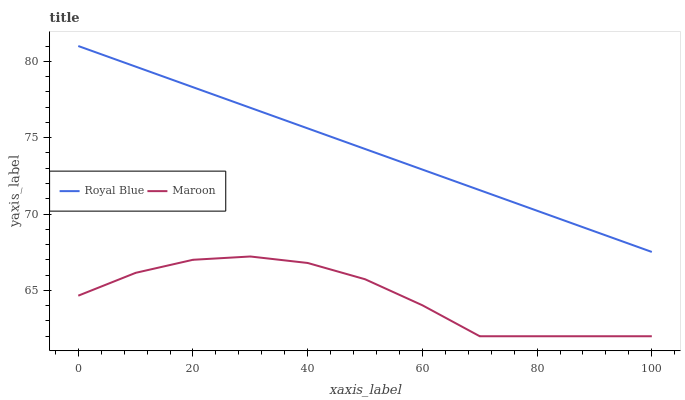Does Maroon have the minimum area under the curve?
Answer yes or no. Yes. Does Royal Blue have the maximum area under the curve?
Answer yes or no. Yes. Does Maroon have the maximum area under the curve?
Answer yes or no. No. Is Royal Blue the smoothest?
Answer yes or no. Yes. Is Maroon the roughest?
Answer yes or no. Yes. Is Maroon the smoothest?
Answer yes or no. No. Does Royal Blue have the highest value?
Answer yes or no. Yes. Does Maroon have the highest value?
Answer yes or no. No. Is Maroon less than Royal Blue?
Answer yes or no. Yes. Is Royal Blue greater than Maroon?
Answer yes or no. Yes. Does Maroon intersect Royal Blue?
Answer yes or no. No. 